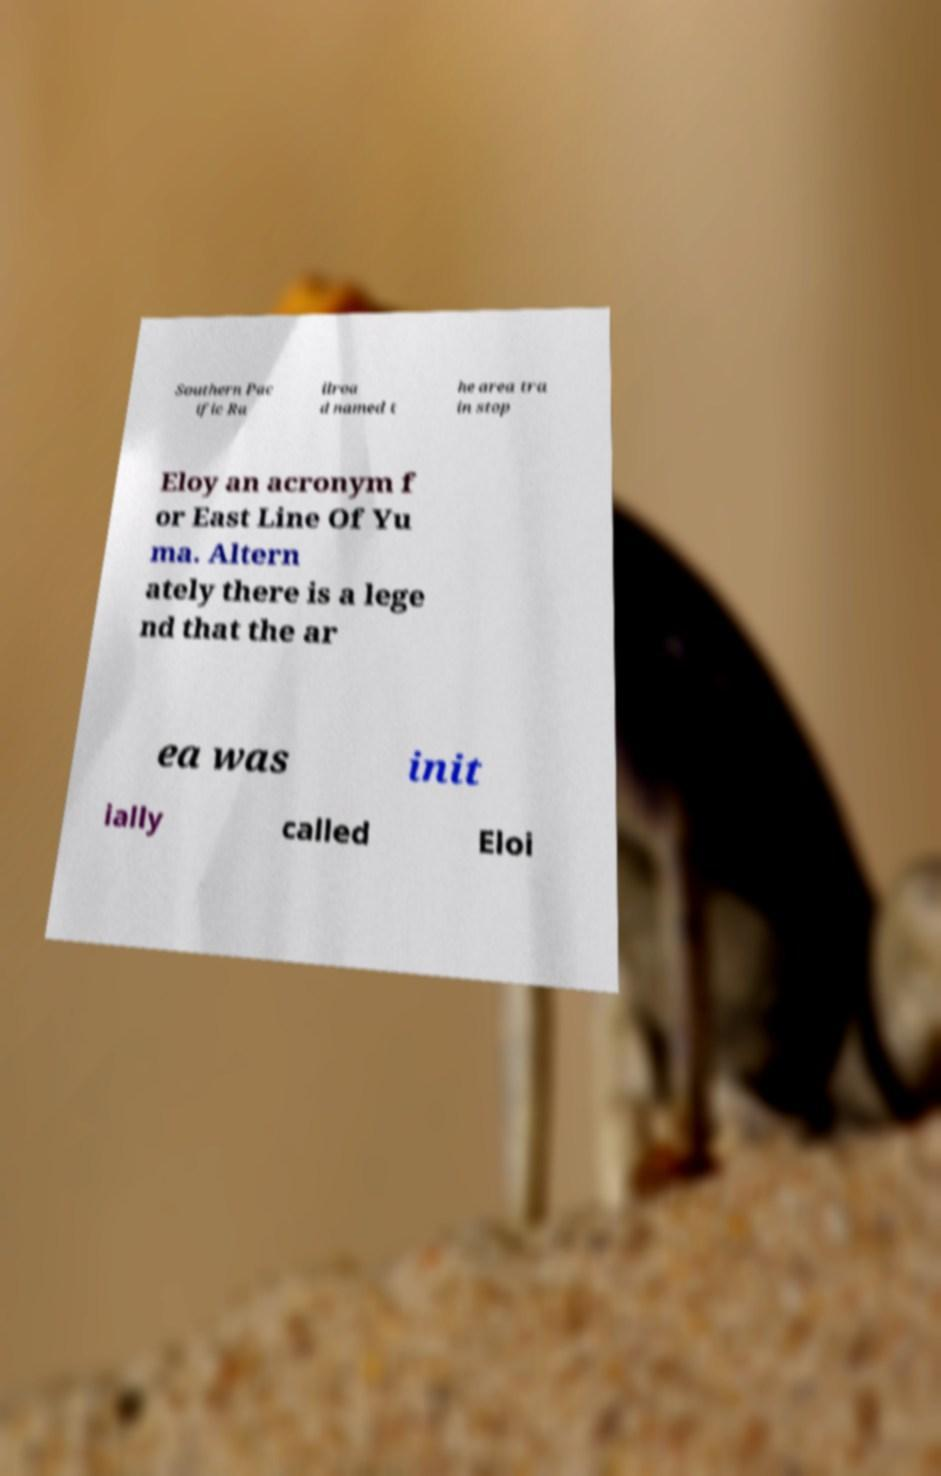Could you extract and type out the text from this image? Southern Pac ific Ra ilroa d named t he area tra in stop Eloy an acronym f or East Line Of Yu ma. Altern ately there is a lege nd that the ar ea was init ially called Eloi 